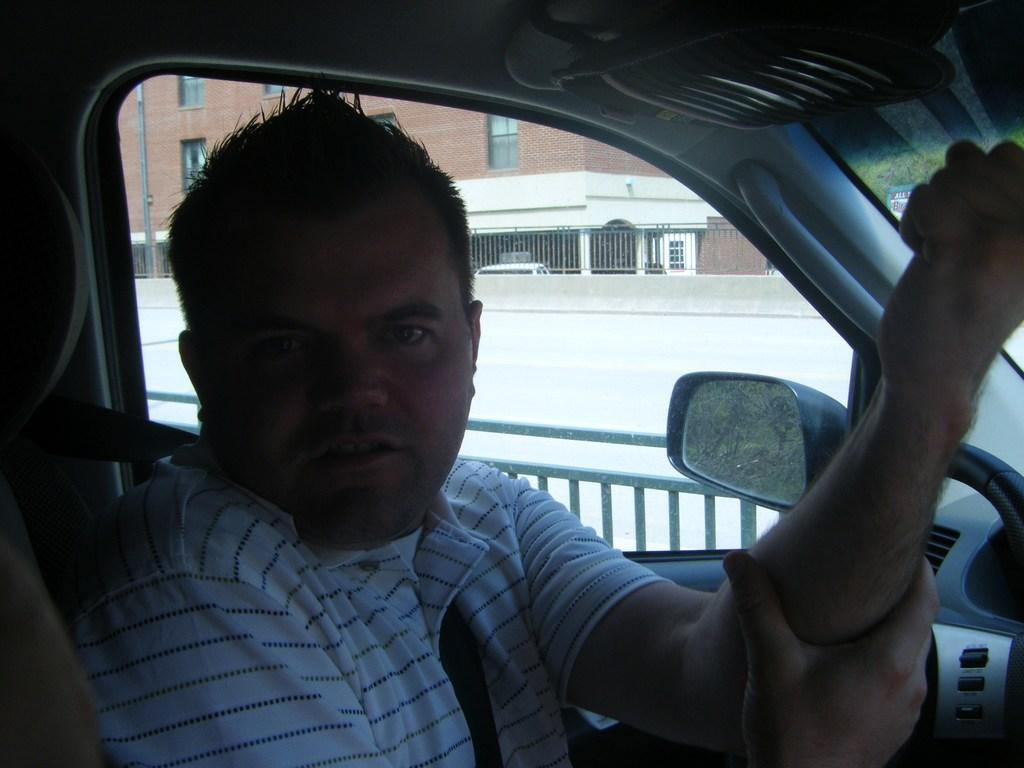What is happening inside the vehicle in the image? There is a man inside the vehicle, and he is holding his own hand. What can be seen in the background of the image? There are barrel gates and at least one building visible in the background of the image. Are there any openings visible in the background? Yes, there are windows visible in the background of the image. What type of bat can be seen flying around the vehicle in the image? There is no bat present in the image; it only features a man inside a vehicle, barrel gates, buildings, and windows in the background. 